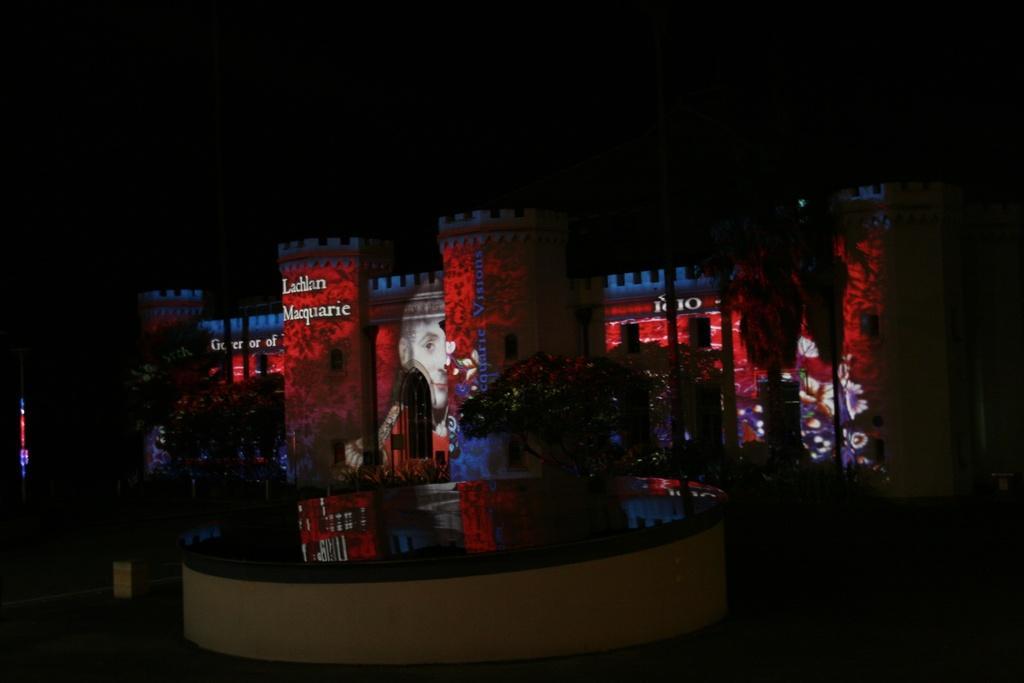In one or two sentences, can you explain what this image depicts? This picture is taken in dark. There are few trees. Behind there is a castle having few pictures painted on the wall of it. Bottom of the image there is wall. Behind there is water. 